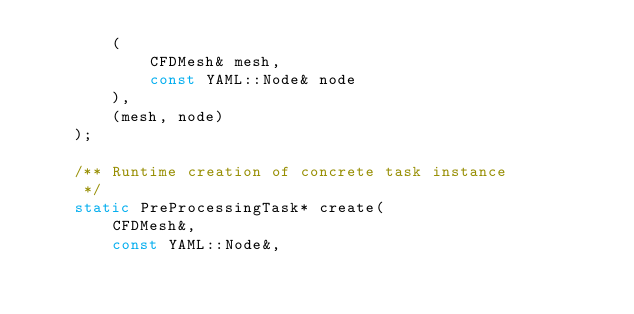<code> <loc_0><loc_0><loc_500><loc_500><_C_>        (
            CFDMesh& mesh,
            const YAML::Node& node
        ),
        (mesh, node)
    );

    /** Runtime creation of concrete task instance
     */
    static PreProcessingTask* create(
        CFDMesh&,
        const YAML::Node&,</code> 